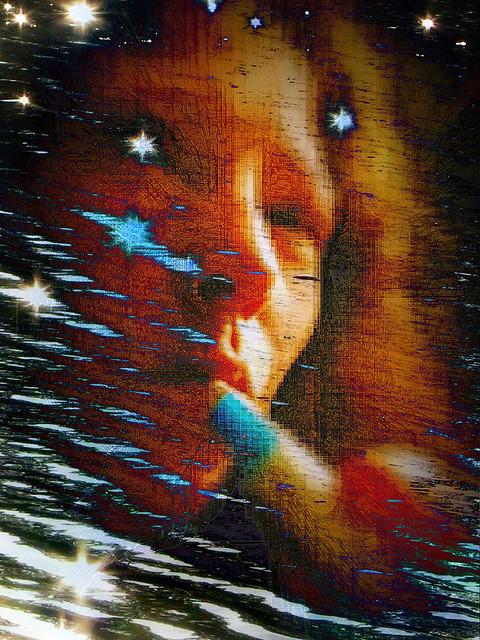Has this photo been photoshopped?
Write a very short answer. Yes. Does this photo has high resolution?
Keep it brief. No. Is this an actual photograph?
Short answer required. No. 